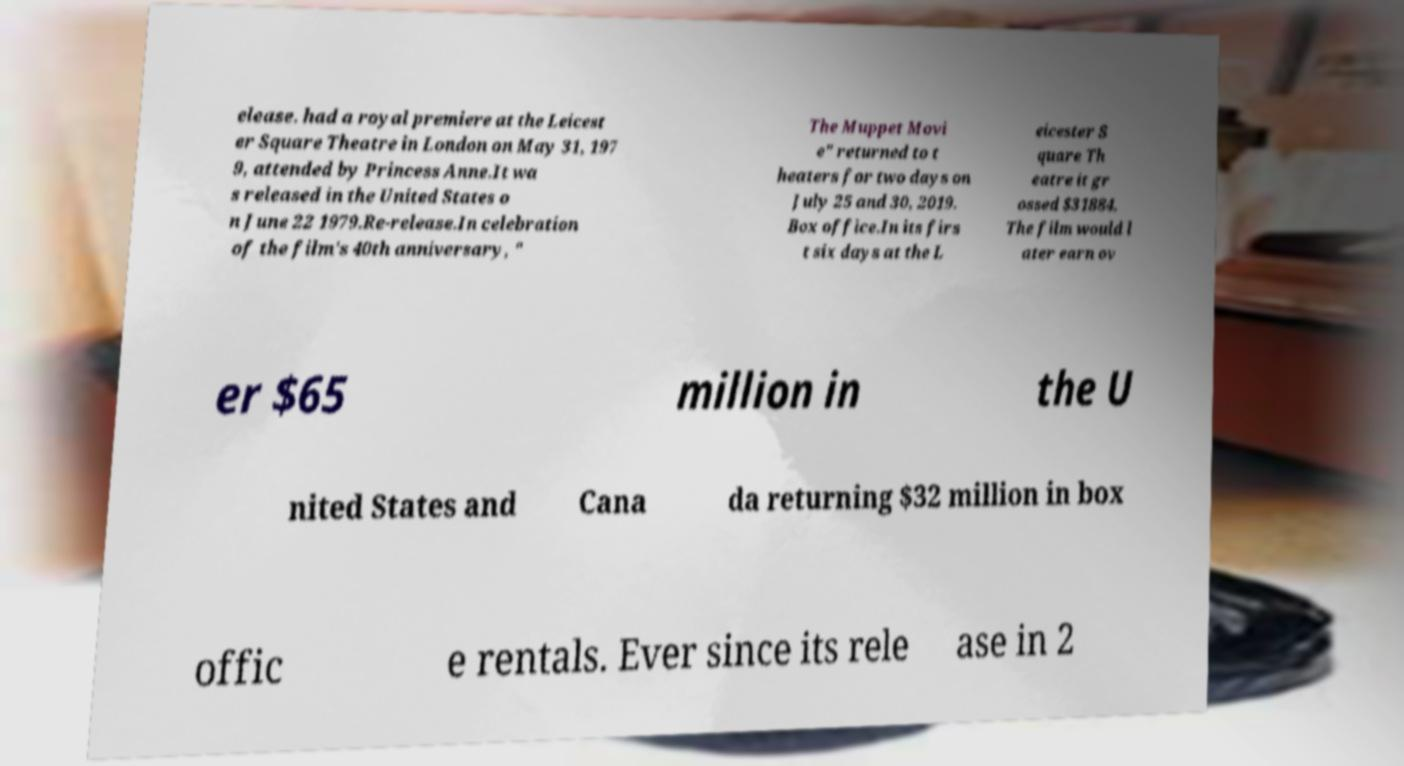Could you extract and type out the text from this image? elease. had a royal premiere at the Leicest er Square Theatre in London on May 31, 197 9, attended by Princess Anne.It wa s released in the United States o n June 22 1979.Re-release.In celebration of the film's 40th anniversary, " The Muppet Movi e" returned to t heaters for two days on July 25 and 30, 2019. Box office.In its firs t six days at the L eicester S quare Th eatre it gr ossed $31884. The film would l ater earn ov er $65 million in the U nited States and Cana da returning $32 million in box offic e rentals. Ever since its rele ase in 2 